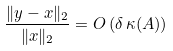Convert formula to latex. <formula><loc_0><loc_0><loc_500><loc_500>\frac { \| y - x \| _ { 2 } } { \| x \| _ { 2 } } = O \left ( \delta \, \kappa ( A ) \right )</formula> 